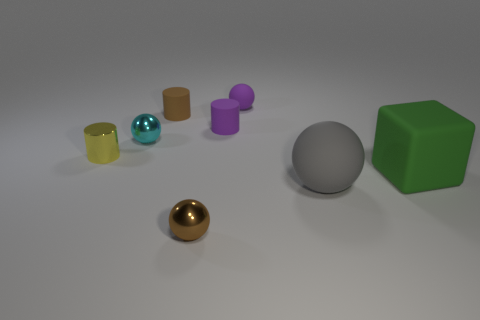Is the color of the small matte ball the same as the small matte cylinder to the right of the brown cylinder?
Your answer should be very brief. Yes. Is the number of brown metal blocks greater than the number of tiny yellow things?
Your answer should be compact. No. The small rubber sphere has what color?
Provide a short and direct response. Purple. There is a matte sphere in front of the small yellow metallic cylinder; is its color the same as the tiny matte ball?
Provide a short and direct response. No. What number of small rubber balls are the same color as the large ball?
Keep it short and to the point. 0. Do the tiny metal object in front of the large green cube and the tiny cyan metal thing have the same shape?
Make the answer very short. Yes. Is the number of big green objects left of the brown sphere less than the number of small metallic balls that are in front of the metal cylinder?
Offer a terse response. Yes. What material is the small brown thing in front of the cyan sphere?
Make the answer very short. Metal. Are there any brown objects that have the same size as the metal cylinder?
Offer a terse response. Yes. Is the shape of the gray thing the same as the large rubber thing on the right side of the big gray thing?
Make the answer very short. No. 